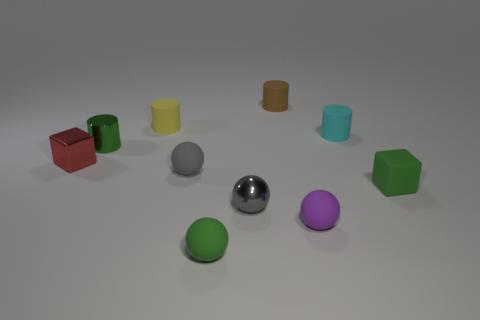Is the number of tiny metal cubes less than the number of gray objects?
Provide a short and direct response. Yes. How many objects have the same color as the small matte block?
Offer a terse response. 2. There is a cylinder that is the same color as the matte block; what material is it?
Your answer should be compact. Metal. Do the matte cube and the tiny cylinder in front of the small cyan cylinder have the same color?
Make the answer very short. Yes. Are there more small rubber blocks than objects?
Offer a terse response. No. What size is the green rubber object that is the same shape as the tiny purple object?
Offer a terse response. Small. Do the small red block and the tiny gray thing right of the green matte sphere have the same material?
Provide a succinct answer. Yes. What number of things are green matte cubes or tiny green objects?
Give a very brief answer. 3. What number of spheres are small cyan matte objects or tiny purple rubber things?
Provide a succinct answer. 1. Is there a small yellow thing?
Your answer should be compact. Yes. 